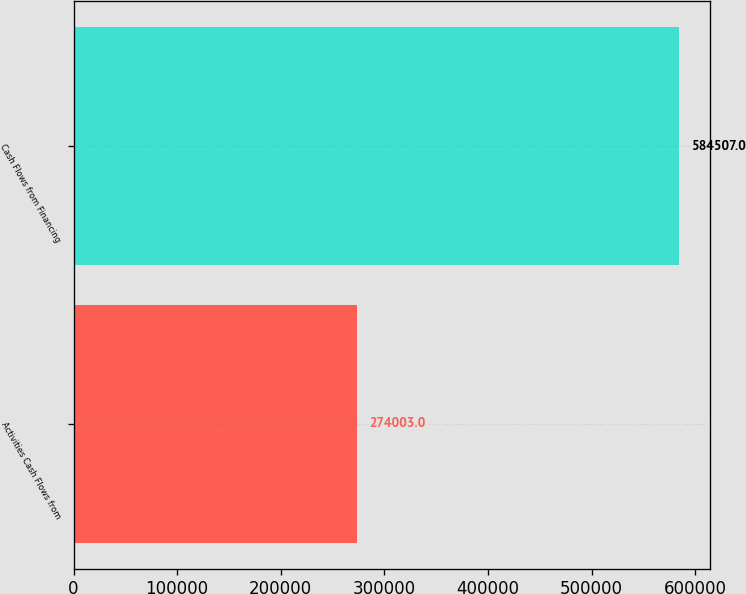Convert chart to OTSL. <chart><loc_0><loc_0><loc_500><loc_500><bar_chart><fcel>Activities Cash Flows from<fcel>Cash Flows from Financing<nl><fcel>274003<fcel>584507<nl></chart> 